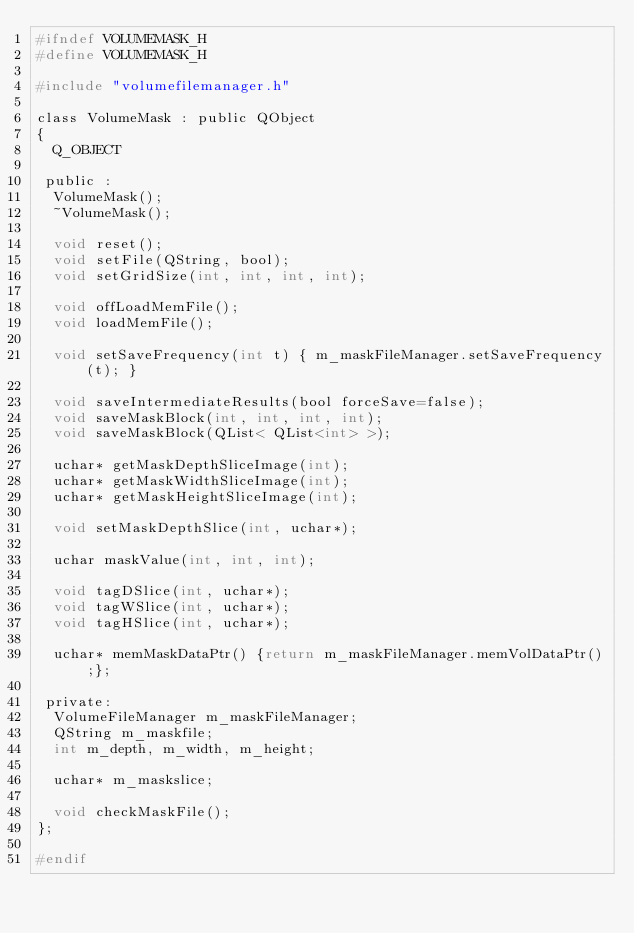<code> <loc_0><loc_0><loc_500><loc_500><_C_>#ifndef VOLUMEMASK_H
#define VOLUMEMASK_H

#include "volumefilemanager.h"

class VolumeMask : public QObject
{
  Q_OBJECT

 public :
  VolumeMask();
  ~VolumeMask();

  void reset();
  void setFile(QString, bool);
  void setGridSize(int, int, int, int);

  void offLoadMemFile();
  void loadMemFile();

  void setSaveFrequency(int t) { m_maskFileManager.setSaveFrequency(t); }

  void saveIntermediateResults(bool forceSave=false);
  void saveMaskBlock(int, int, int, int);
  void saveMaskBlock(QList< QList<int> >);

  uchar* getMaskDepthSliceImage(int);
  uchar* getMaskWidthSliceImage(int);
  uchar* getMaskHeightSliceImage(int);

  void setMaskDepthSlice(int, uchar*);

  uchar maskValue(int, int, int);

  void tagDSlice(int, uchar*);
  void tagWSlice(int, uchar*);
  void tagHSlice(int, uchar*);

  uchar* memMaskDataPtr() {return m_maskFileManager.memVolDataPtr();};

 private:
  VolumeFileManager m_maskFileManager;
  QString m_maskfile;
  int m_depth, m_width, m_height;

  uchar* m_maskslice;

  void checkMaskFile();
};

#endif
</code> 